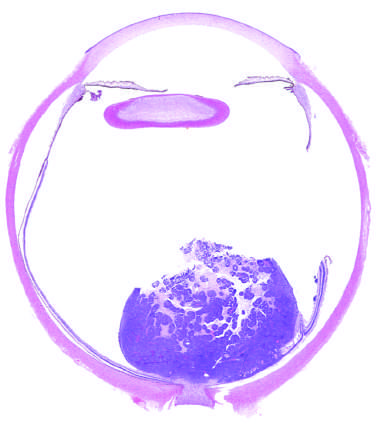s the tan-colored, encapsulated small tumor seen abutting the optic nerve?
Answer the question using a single word or phrase. No 